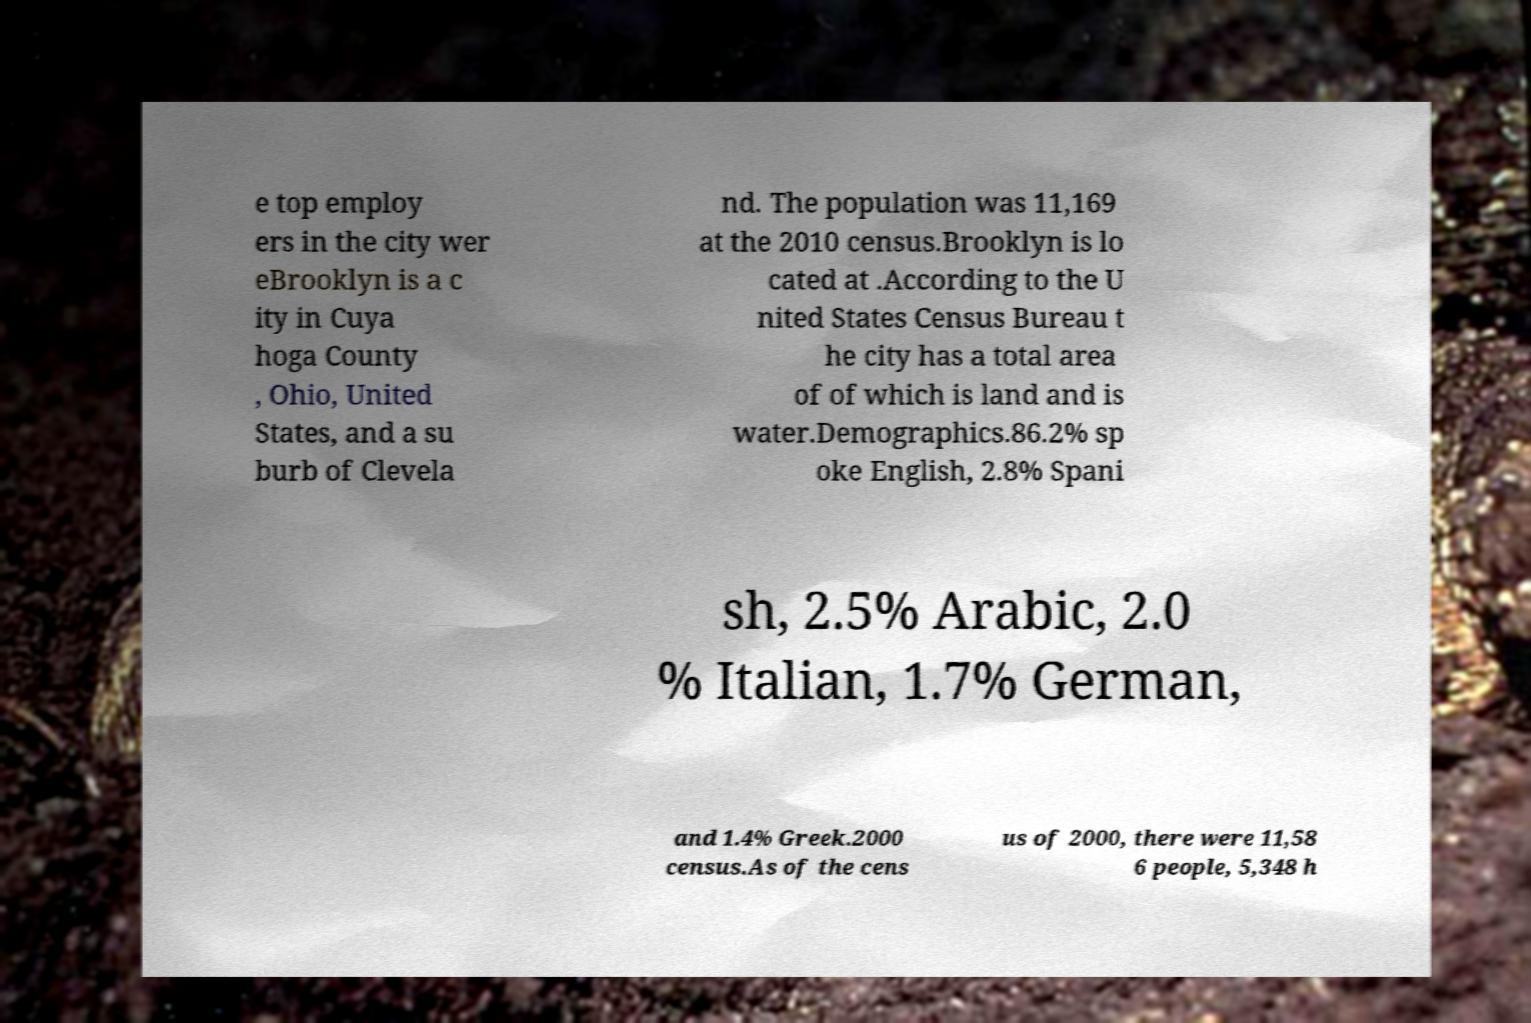Please read and relay the text visible in this image. What does it say? e top employ ers in the city wer eBrooklyn is a c ity in Cuya hoga County , Ohio, United States, and a su burb of Clevela nd. The population was 11,169 at the 2010 census.Brooklyn is lo cated at .According to the U nited States Census Bureau t he city has a total area of of which is land and is water.Demographics.86.2% sp oke English, 2.8% Spani sh, 2.5% Arabic, 2.0 % Italian, 1.7% German, and 1.4% Greek.2000 census.As of the cens us of 2000, there were 11,58 6 people, 5,348 h 